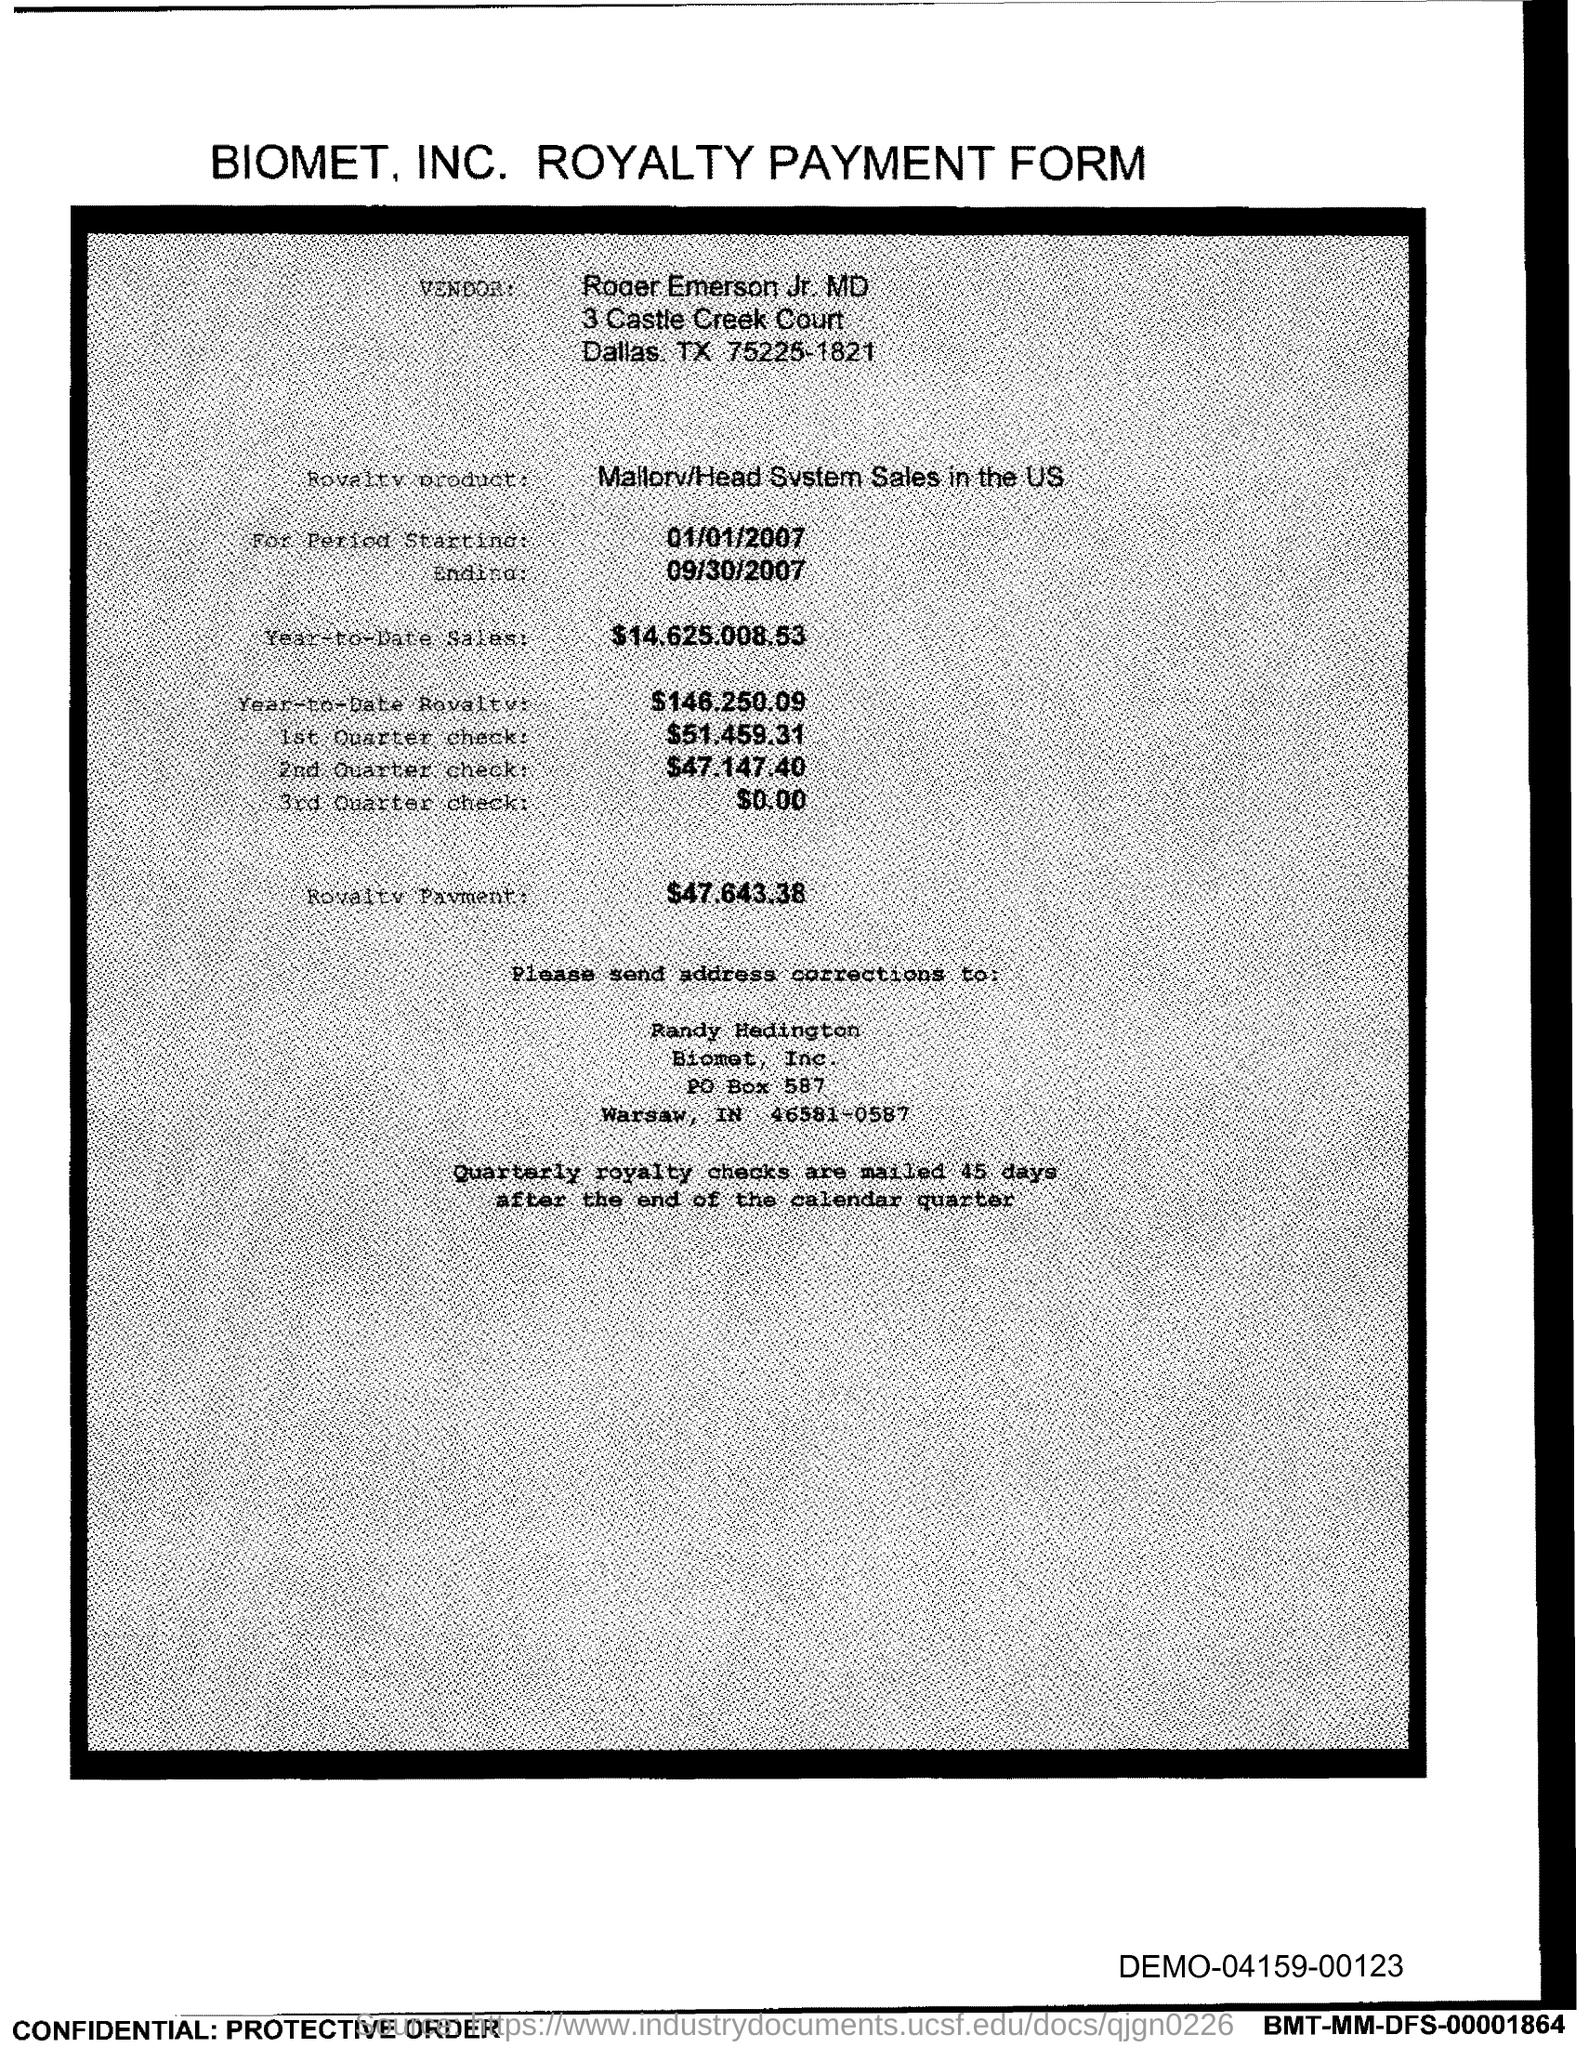Please provide the address and contact details for sending address corrections. The address for sending address corrections is to Randy Hedington at Biomet, Inc., PO Box 587, Warsaw, IN 46581-0587. 